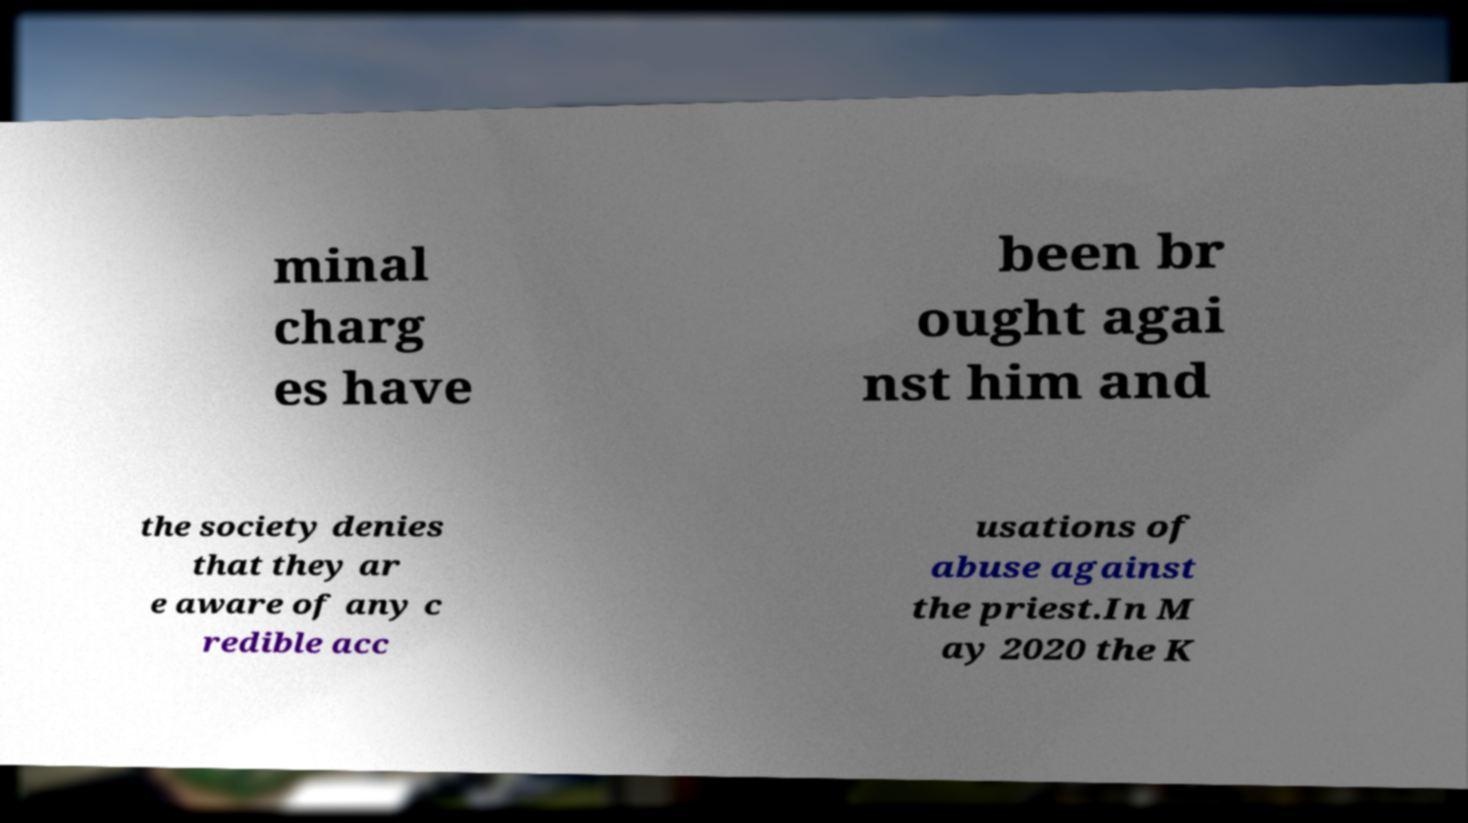Can you accurately transcribe the text from the provided image for me? minal charg es have been br ought agai nst him and the society denies that they ar e aware of any c redible acc usations of abuse against the priest.In M ay 2020 the K 